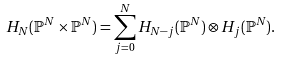Convert formula to latex. <formula><loc_0><loc_0><loc_500><loc_500>H _ { N } ( \mathbb { P } ^ { N } \times \mathbb { P } ^ { N } ) = \sum _ { j = 0 } ^ { N } H _ { N - j } ( \mathbb { P } ^ { N } ) \otimes H _ { j } ( \mathbb { P } ^ { N } ) .</formula> 